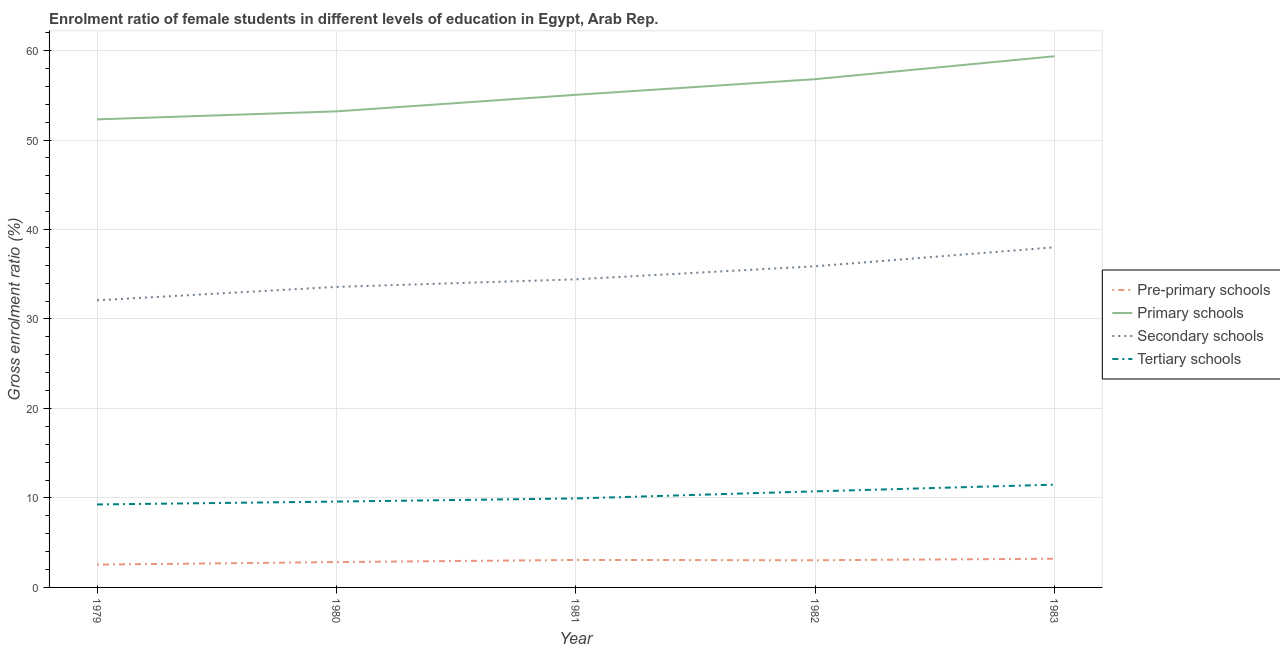How many different coloured lines are there?
Offer a terse response. 4. Does the line corresponding to gross enrolment ratio(male) in primary schools intersect with the line corresponding to gross enrolment ratio(male) in secondary schools?
Your answer should be compact. No. Is the number of lines equal to the number of legend labels?
Give a very brief answer. Yes. What is the gross enrolment ratio(male) in pre-primary schools in 1980?
Keep it short and to the point. 2.83. Across all years, what is the maximum gross enrolment ratio(male) in secondary schools?
Your answer should be compact. 38.01. Across all years, what is the minimum gross enrolment ratio(male) in secondary schools?
Keep it short and to the point. 32.09. In which year was the gross enrolment ratio(male) in pre-primary schools maximum?
Provide a short and direct response. 1983. In which year was the gross enrolment ratio(male) in primary schools minimum?
Your response must be concise. 1979. What is the total gross enrolment ratio(male) in tertiary schools in the graph?
Make the answer very short. 51.03. What is the difference between the gross enrolment ratio(male) in tertiary schools in 1979 and that in 1982?
Offer a terse response. -1.47. What is the difference between the gross enrolment ratio(male) in secondary schools in 1981 and the gross enrolment ratio(male) in primary schools in 1980?
Offer a very short reply. -18.77. What is the average gross enrolment ratio(male) in tertiary schools per year?
Your answer should be very brief. 10.21. In the year 1983, what is the difference between the gross enrolment ratio(male) in tertiary schools and gross enrolment ratio(male) in primary schools?
Provide a succinct answer. -47.88. In how many years, is the gross enrolment ratio(male) in primary schools greater than 20 %?
Offer a terse response. 5. What is the ratio of the gross enrolment ratio(male) in pre-primary schools in 1982 to that in 1983?
Your response must be concise. 0.95. Is the gross enrolment ratio(male) in primary schools in 1979 less than that in 1983?
Offer a terse response. Yes. Is the difference between the gross enrolment ratio(male) in pre-primary schools in 1979 and 1980 greater than the difference between the gross enrolment ratio(male) in primary schools in 1979 and 1980?
Your response must be concise. Yes. What is the difference between the highest and the second highest gross enrolment ratio(male) in tertiary schools?
Your response must be concise. 0.75. What is the difference between the highest and the lowest gross enrolment ratio(male) in secondary schools?
Give a very brief answer. 5.92. Is the sum of the gross enrolment ratio(male) in primary schools in 1980 and 1982 greater than the maximum gross enrolment ratio(male) in secondary schools across all years?
Offer a terse response. Yes. Is it the case that in every year, the sum of the gross enrolment ratio(male) in pre-primary schools and gross enrolment ratio(male) in primary schools is greater than the gross enrolment ratio(male) in secondary schools?
Your response must be concise. Yes. How many lines are there?
Keep it short and to the point. 4. How many legend labels are there?
Offer a terse response. 4. How are the legend labels stacked?
Give a very brief answer. Vertical. What is the title of the graph?
Give a very brief answer. Enrolment ratio of female students in different levels of education in Egypt, Arab Rep. Does "Structural Policies" appear as one of the legend labels in the graph?
Ensure brevity in your answer.  No. What is the label or title of the Y-axis?
Provide a succinct answer. Gross enrolment ratio (%). What is the Gross enrolment ratio (%) of Pre-primary schools in 1979?
Provide a short and direct response. 2.55. What is the Gross enrolment ratio (%) of Primary schools in 1979?
Provide a short and direct response. 52.3. What is the Gross enrolment ratio (%) in Secondary schools in 1979?
Offer a terse response. 32.09. What is the Gross enrolment ratio (%) in Tertiary schools in 1979?
Your answer should be very brief. 9.27. What is the Gross enrolment ratio (%) of Pre-primary schools in 1980?
Provide a short and direct response. 2.83. What is the Gross enrolment ratio (%) of Primary schools in 1980?
Offer a terse response. 53.2. What is the Gross enrolment ratio (%) in Secondary schools in 1980?
Provide a short and direct response. 33.58. What is the Gross enrolment ratio (%) in Tertiary schools in 1980?
Provide a succinct answer. 9.59. What is the Gross enrolment ratio (%) in Pre-primary schools in 1981?
Offer a very short reply. 3.07. What is the Gross enrolment ratio (%) in Primary schools in 1981?
Your answer should be very brief. 55.05. What is the Gross enrolment ratio (%) in Secondary schools in 1981?
Your answer should be compact. 34.43. What is the Gross enrolment ratio (%) of Tertiary schools in 1981?
Give a very brief answer. 9.94. What is the Gross enrolment ratio (%) in Pre-primary schools in 1982?
Your answer should be very brief. 3.04. What is the Gross enrolment ratio (%) in Primary schools in 1982?
Your answer should be very brief. 56.8. What is the Gross enrolment ratio (%) of Secondary schools in 1982?
Offer a terse response. 35.89. What is the Gross enrolment ratio (%) of Tertiary schools in 1982?
Provide a short and direct response. 10.74. What is the Gross enrolment ratio (%) in Pre-primary schools in 1983?
Offer a very short reply. 3.21. What is the Gross enrolment ratio (%) in Primary schools in 1983?
Your response must be concise. 59.36. What is the Gross enrolment ratio (%) in Secondary schools in 1983?
Give a very brief answer. 38.01. What is the Gross enrolment ratio (%) of Tertiary schools in 1983?
Provide a succinct answer. 11.49. Across all years, what is the maximum Gross enrolment ratio (%) of Pre-primary schools?
Give a very brief answer. 3.21. Across all years, what is the maximum Gross enrolment ratio (%) in Primary schools?
Offer a terse response. 59.36. Across all years, what is the maximum Gross enrolment ratio (%) in Secondary schools?
Provide a short and direct response. 38.01. Across all years, what is the maximum Gross enrolment ratio (%) of Tertiary schools?
Keep it short and to the point. 11.49. Across all years, what is the minimum Gross enrolment ratio (%) of Pre-primary schools?
Ensure brevity in your answer.  2.55. Across all years, what is the minimum Gross enrolment ratio (%) of Primary schools?
Keep it short and to the point. 52.3. Across all years, what is the minimum Gross enrolment ratio (%) in Secondary schools?
Provide a short and direct response. 32.09. Across all years, what is the minimum Gross enrolment ratio (%) of Tertiary schools?
Provide a succinct answer. 9.27. What is the total Gross enrolment ratio (%) of Pre-primary schools in the graph?
Provide a short and direct response. 14.7. What is the total Gross enrolment ratio (%) in Primary schools in the graph?
Make the answer very short. 276.71. What is the total Gross enrolment ratio (%) of Secondary schools in the graph?
Provide a short and direct response. 174. What is the total Gross enrolment ratio (%) in Tertiary schools in the graph?
Offer a terse response. 51.03. What is the difference between the Gross enrolment ratio (%) of Pre-primary schools in 1979 and that in 1980?
Make the answer very short. -0.28. What is the difference between the Gross enrolment ratio (%) in Primary schools in 1979 and that in 1980?
Offer a terse response. -0.9. What is the difference between the Gross enrolment ratio (%) in Secondary schools in 1979 and that in 1980?
Give a very brief answer. -1.49. What is the difference between the Gross enrolment ratio (%) in Tertiary schools in 1979 and that in 1980?
Give a very brief answer. -0.32. What is the difference between the Gross enrolment ratio (%) in Pre-primary schools in 1979 and that in 1981?
Ensure brevity in your answer.  -0.52. What is the difference between the Gross enrolment ratio (%) of Primary schools in 1979 and that in 1981?
Keep it short and to the point. -2.75. What is the difference between the Gross enrolment ratio (%) of Secondary schools in 1979 and that in 1981?
Give a very brief answer. -2.34. What is the difference between the Gross enrolment ratio (%) of Tertiary schools in 1979 and that in 1981?
Make the answer very short. -0.67. What is the difference between the Gross enrolment ratio (%) of Pre-primary schools in 1979 and that in 1982?
Keep it short and to the point. -0.49. What is the difference between the Gross enrolment ratio (%) in Primary schools in 1979 and that in 1982?
Keep it short and to the point. -4.49. What is the difference between the Gross enrolment ratio (%) of Secondary schools in 1979 and that in 1982?
Make the answer very short. -3.8. What is the difference between the Gross enrolment ratio (%) in Tertiary schools in 1979 and that in 1982?
Your answer should be compact. -1.47. What is the difference between the Gross enrolment ratio (%) of Pre-primary schools in 1979 and that in 1983?
Keep it short and to the point. -0.66. What is the difference between the Gross enrolment ratio (%) in Primary schools in 1979 and that in 1983?
Ensure brevity in your answer.  -7.06. What is the difference between the Gross enrolment ratio (%) in Secondary schools in 1979 and that in 1983?
Your answer should be compact. -5.92. What is the difference between the Gross enrolment ratio (%) in Tertiary schools in 1979 and that in 1983?
Provide a short and direct response. -2.21. What is the difference between the Gross enrolment ratio (%) in Pre-primary schools in 1980 and that in 1981?
Ensure brevity in your answer.  -0.24. What is the difference between the Gross enrolment ratio (%) in Primary schools in 1980 and that in 1981?
Your answer should be very brief. -1.85. What is the difference between the Gross enrolment ratio (%) of Secondary schools in 1980 and that in 1981?
Give a very brief answer. -0.85. What is the difference between the Gross enrolment ratio (%) in Tertiary schools in 1980 and that in 1981?
Offer a very short reply. -0.35. What is the difference between the Gross enrolment ratio (%) of Pre-primary schools in 1980 and that in 1982?
Offer a very short reply. -0.21. What is the difference between the Gross enrolment ratio (%) of Primary schools in 1980 and that in 1982?
Keep it short and to the point. -3.6. What is the difference between the Gross enrolment ratio (%) of Secondary schools in 1980 and that in 1982?
Offer a terse response. -2.3. What is the difference between the Gross enrolment ratio (%) of Tertiary schools in 1980 and that in 1982?
Make the answer very short. -1.14. What is the difference between the Gross enrolment ratio (%) of Pre-primary schools in 1980 and that in 1983?
Your answer should be compact. -0.37. What is the difference between the Gross enrolment ratio (%) in Primary schools in 1980 and that in 1983?
Offer a very short reply. -6.16. What is the difference between the Gross enrolment ratio (%) in Secondary schools in 1980 and that in 1983?
Offer a terse response. -4.43. What is the difference between the Gross enrolment ratio (%) of Tertiary schools in 1980 and that in 1983?
Give a very brief answer. -1.89. What is the difference between the Gross enrolment ratio (%) in Pre-primary schools in 1981 and that in 1982?
Keep it short and to the point. 0.03. What is the difference between the Gross enrolment ratio (%) in Primary schools in 1981 and that in 1982?
Make the answer very short. -1.75. What is the difference between the Gross enrolment ratio (%) of Secondary schools in 1981 and that in 1982?
Your answer should be very brief. -1.46. What is the difference between the Gross enrolment ratio (%) in Tertiary schools in 1981 and that in 1982?
Your answer should be compact. -0.79. What is the difference between the Gross enrolment ratio (%) in Pre-primary schools in 1981 and that in 1983?
Your response must be concise. -0.13. What is the difference between the Gross enrolment ratio (%) of Primary schools in 1981 and that in 1983?
Ensure brevity in your answer.  -4.31. What is the difference between the Gross enrolment ratio (%) in Secondary schools in 1981 and that in 1983?
Offer a very short reply. -3.58. What is the difference between the Gross enrolment ratio (%) of Tertiary schools in 1981 and that in 1983?
Ensure brevity in your answer.  -1.54. What is the difference between the Gross enrolment ratio (%) of Pre-primary schools in 1982 and that in 1983?
Give a very brief answer. -0.17. What is the difference between the Gross enrolment ratio (%) of Primary schools in 1982 and that in 1983?
Provide a succinct answer. -2.56. What is the difference between the Gross enrolment ratio (%) of Secondary schools in 1982 and that in 1983?
Offer a terse response. -2.13. What is the difference between the Gross enrolment ratio (%) in Tertiary schools in 1982 and that in 1983?
Make the answer very short. -0.75. What is the difference between the Gross enrolment ratio (%) in Pre-primary schools in 1979 and the Gross enrolment ratio (%) in Primary schools in 1980?
Make the answer very short. -50.65. What is the difference between the Gross enrolment ratio (%) in Pre-primary schools in 1979 and the Gross enrolment ratio (%) in Secondary schools in 1980?
Make the answer very short. -31.04. What is the difference between the Gross enrolment ratio (%) of Pre-primary schools in 1979 and the Gross enrolment ratio (%) of Tertiary schools in 1980?
Offer a very short reply. -7.05. What is the difference between the Gross enrolment ratio (%) in Primary schools in 1979 and the Gross enrolment ratio (%) in Secondary schools in 1980?
Your answer should be compact. 18.72. What is the difference between the Gross enrolment ratio (%) in Primary schools in 1979 and the Gross enrolment ratio (%) in Tertiary schools in 1980?
Ensure brevity in your answer.  42.71. What is the difference between the Gross enrolment ratio (%) in Secondary schools in 1979 and the Gross enrolment ratio (%) in Tertiary schools in 1980?
Offer a terse response. 22.49. What is the difference between the Gross enrolment ratio (%) in Pre-primary schools in 1979 and the Gross enrolment ratio (%) in Primary schools in 1981?
Give a very brief answer. -52.5. What is the difference between the Gross enrolment ratio (%) in Pre-primary schools in 1979 and the Gross enrolment ratio (%) in Secondary schools in 1981?
Offer a very short reply. -31.88. What is the difference between the Gross enrolment ratio (%) of Pre-primary schools in 1979 and the Gross enrolment ratio (%) of Tertiary schools in 1981?
Make the answer very short. -7.4. What is the difference between the Gross enrolment ratio (%) in Primary schools in 1979 and the Gross enrolment ratio (%) in Secondary schools in 1981?
Your response must be concise. 17.87. What is the difference between the Gross enrolment ratio (%) of Primary schools in 1979 and the Gross enrolment ratio (%) of Tertiary schools in 1981?
Keep it short and to the point. 42.36. What is the difference between the Gross enrolment ratio (%) in Secondary schools in 1979 and the Gross enrolment ratio (%) in Tertiary schools in 1981?
Keep it short and to the point. 22.15. What is the difference between the Gross enrolment ratio (%) in Pre-primary schools in 1979 and the Gross enrolment ratio (%) in Primary schools in 1982?
Give a very brief answer. -54.25. What is the difference between the Gross enrolment ratio (%) in Pre-primary schools in 1979 and the Gross enrolment ratio (%) in Secondary schools in 1982?
Your answer should be compact. -33.34. What is the difference between the Gross enrolment ratio (%) in Pre-primary schools in 1979 and the Gross enrolment ratio (%) in Tertiary schools in 1982?
Keep it short and to the point. -8.19. What is the difference between the Gross enrolment ratio (%) in Primary schools in 1979 and the Gross enrolment ratio (%) in Secondary schools in 1982?
Keep it short and to the point. 16.42. What is the difference between the Gross enrolment ratio (%) in Primary schools in 1979 and the Gross enrolment ratio (%) in Tertiary schools in 1982?
Make the answer very short. 41.57. What is the difference between the Gross enrolment ratio (%) of Secondary schools in 1979 and the Gross enrolment ratio (%) of Tertiary schools in 1982?
Give a very brief answer. 21.35. What is the difference between the Gross enrolment ratio (%) of Pre-primary schools in 1979 and the Gross enrolment ratio (%) of Primary schools in 1983?
Ensure brevity in your answer.  -56.81. What is the difference between the Gross enrolment ratio (%) in Pre-primary schools in 1979 and the Gross enrolment ratio (%) in Secondary schools in 1983?
Your response must be concise. -35.47. What is the difference between the Gross enrolment ratio (%) of Pre-primary schools in 1979 and the Gross enrolment ratio (%) of Tertiary schools in 1983?
Make the answer very short. -8.94. What is the difference between the Gross enrolment ratio (%) of Primary schools in 1979 and the Gross enrolment ratio (%) of Secondary schools in 1983?
Your answer should be compact. 14.29. What is the difference between the Gross enrolment ratio (%) of Primary schools in 1979 and the Gross enrolment ratio (%) of Tertiary schools in 1983?
Give a very brief answer. 40.82. What is the difference between the Gross enrolment ratio (%) in Secondary schools in 1979 and the Gross enrolment ratio (%) in Tertiary schools in 1983?
Provide a short and direct response. 20.6. What is the difference between the Gross enrolment ratio (%) in Pre-primary schools in 1980 and the Gross enrolment ratio (%) in Primary schools in 1981?
Your response must be concise. -52.22. What is the difference between the Gross enrolment ratio (%) in Pre-primary schools in 1980 and the Gross enrolment ratio (%) in Secondary schools in 1981?
Your answer should be compact. -31.6. What is the difference between the Gross enrolment ratio (%) in Pre-primary schools in 1980 and the Gross enrolment ratio (%) in Tertiary schools in 1981?
Give a very brief answer. -7.11. What is the difference between the Gross enrolment ratio (%) in Primary schools in 1980 and the Gross enrolment ratio (%) in Secondary schools in 1981?
Make the answer very short. 18.77. What is the difference between the Gross enrolment ratio (%) in Primary schools in 1980 and the Gross enrolment ratio (%) in Tertiary schools in 1981?
Ensure brevity in your answer.  43.26. What is the difference between the Gross enrolment ratio (%) in Secondary schools in 1980 and the Gross enrolment ratio (%) in Tertiary schools in 1981?
Keep it short and to the point. 23.64. What is the difference between the Gross enrolment ratio (%) of Pre-primary schools in 1980 and the Gross enrolment ratio (%) of Primary schools in 1982?
Your response must be concise. -53.97. What is the difference between the Gross enrolment ratio (%) in Pre-primary schools in 1980 and the Gross enrolment ratio (%) in Secondary schools in 1982?
Keep it short and to the point. -33.06. What is the difference between the Gross enrolment ratio (%) in Pre-primary schools in 1980 and the Gross enrolment ratio (%) in Tertiary schools in 1982?
Provide a short and direct response. -7.91. What is the difference between the Gross enrolment ratio (%) of Primary schools in 1980 and the Gross enrolment ratio (%) of Secondary schools in 1982?
Make the answer very short. 17.31. What is the difference between the Gross enrolment ratio (%) in Primary schools in 1980 and the Gross enrolment ratio (%) in Tertiary schools in 1982?
Your response must be concise. 42.46. What is the difference between the Gross enrolment ratio (%) of Secondary schools in 1980 and the Gross enrolment ratio (%) of Tertiary schools in 1982?
Your response must be concise. 22.85. What is the difference between the Gross enrolment ratio (%) in Pre-primary schools in 1980 and the Gross enrolment ratio (%) in Primary schools in 1983?
Your answer should be compact. -56.53. What is the difference between the Gross enrolment ratio (%) of Pre-primary schools in 1980 and the Gross enrolment ratio (%) of Secondary schools in 1983?
Make the answer very short. -35.18. What is the difference between the Gross enrolment ratio (%) of Pre-primary schools in 1980 and the Gross enrolment ratio (%) of Tertiary schools in 1983?
Keep it short and to the point. -8.65. What is the difference between the Gross enrolment ratio (%) of Primary schools in 1980 and the Gross enrolment ratio (%) of Secondary schools in 1983?
Offer a terse response. 15.19. What is the difference between the Gross enrolment ratio (%) of Primary schools in 1980 and the Gross enrolment ratio (%) of Tertiary schools in 1983?
Keep it short and to the point. 41.72. What is the difference between the Gross enrolment ratio (%) in Secondary schools in 1980 and the Gross enrolment ratio (%) in Tertiary schools in 1983?
Provide a short and direct response. 22.1. What is the difference between the Gross enrolment ratio (%) of Pre-primary schools in 1981 and the Gross enrolment ratio (%) of Primary schools in 1982?
Your answer should be very brief. -53.73. What is the difference between the Gross enrolment ratio (%) of Pre-primary schools in 1981 and the Gross enrolment ratio (%) of Secondary schools in 1982?
Provide a succinct answer. -32.81. What is the difference between the Gross enrolment ratio (%) in Pre-primary schools in 1981 and the Gross enrolment ratio (%) in Tertiary schools in 1982?
Ensure brevity in your answer.  -7.67. What is the difference between the Gross enrolment ratio (%) in Primary schools in 1981 and the Gross enrolment ratio (%) in Secondary schools in 1982?
Your answer should be compact. 19.17. What is the difference between the Gross enrolment ratio (%) in Primary schools in 1981 and the Gross enrolment ratio (%) in Tertiary schools in 1982?
Your answer should be compact. 44.31. What is the difference between the Gross enrolment ratio (%) of Secondary schools in 1981 and the Gross enrolment ratio (%) of Tertiary schools in 1982?
Provide a short and direct response. 23.69. What is the difference between the Gross enrolment ratio (%) in Pre-primary schools in 1981 and the Gross enrolment ratio (%) in Primary schools in 1983?
Give a very brief answer. -56.29. What is the difference between the Gross enrolment ratio (%) of Pre-primary schools in 1981 and the Gross enrolment ratio (%) of Secondary schools in 1983?
Keep it short and to the point. -34.94. What is the difference between the Gross enrolment ratio (%) of Pre-primary schools in 1981 and the Gross enrolment ratio (%) of Tertiary schools in 1983?
Your response must be concise. -8.41. What is the difference between the Gross enrolment ratio (%) of Primary schools in 1981 and the Gross enrolment ratio (%) of Secondary schools in 1983?
Offer a very short reply. 17.04. What is the difference between the Gross enrolment ratio (%) of Primary schools in 1981 and the Gross enrolment ratio (%) of Tertiary schools in 1983?
Offer a terse response. 43.57. What is the difference between the Gross enrolment ratio (%) in Secondary schools in 1981 and the Gross enrolment ratio (%) in Tertiary schools in 1983?
Offer a terse response. 22.94. What is the difference between the Gross enrolment ratio (%) of Pre-primary schools in 1982 and the Gross enrolment ratio (%) of Primary schools in 1983?
Ensure brevity in your answer.  -56.32. What is the difference between the Gross enrolment ratio (%) in Pre-primary schools in 1982 and the Gross enrolment ratio (%) in Secondary schools in 1983?
Keep it short and to the point. -34.97. What is the difference between the Gross enrolment ratio (%) in Pre-primary schools in 1982 and the Gross enrolment ratio (%) in Tertiary schools in 1983?
Your response must be concise. -8.45. What is the difference between the Gross enrolment ratio (%) of Primary schools in 1982 and the Gross enrolment ratio (%) of Secondary schools in 1983?
Keep it short and to the point. 18.78. What is the difference between the Gross enrolment ratio (%) in Primary schools in 1982 and the Gross enrolment ratio (%) in Tertiary schools in 1983?
Your response must be concise. 45.31. What is the difference between the Gross enrolment ratio (%) of Secondary schools in 1982 and the Gross enrolment ratio (%) of Tertiary schools in 1983?
Keep it short and to the point. 24.4. What is the average Gross enrolment ratio (%) in Pre-primary schools per year?
Keep it short and to the point. 2.94. What is the average Gross enrolment ratio (%) of Primary schools per year?
Your answer should be compact. 55.34. What is the average Gross enrolment ratio (%) of Secondary schools per year?
Provide a succinct answer. 34.8. What is the average Gross enrolment ratio (%) of Tertiary schools per year?
Your response must be concise. 10.21. In the year 1979, what is the difference between the Gross enrolment ratio (%) in Pre-primary schools and Gross enrolment ratio (%) in Primary schools?
Make the answer very short. -49.76. In the year 1979, what is the difference between the Gross enrolment ratio (%) in Pre-primary schools and Gross enrolment ratio (%) in Secondary schools?
Keep it short and to the point. -29.54. In the year 1979, what is the difference between the Gross enrolment ratio (%) in Pre-primary schools and Gross enrolment ratio (%) in Tertiary schools?
Provide a short and direct response. -6.72. In the year 1979, what is the difference between the Gross enrolment ratio (%) of Primary schools and Gross enrolment ratio (%) of Secondary schools?
Your answer should be very brief. 20.21. In the year 1979, what is the difference between the Gross enrolment ratio (%) of Primary schools and Gross enrolment ratio (%) of Tertiary schools?
Keep it short and to the point. 43.03. In the year 1979, what is the difference between the Gross enrolment ratio (%) of Secondary schools and Gross enrolment ratio (%) of Tertiary schools?
Your answer should be very brief. 22.82. In the year 1980, what is the difference between the Gross enrolment ratio (%) of Pre-primary schools and Gross enrolment ratio (%) of Primary schools?
Ensure brevity in your answer.  -50.37. In the year 1980, what is the difference between the Gross enrolment ratio (%) of Pre-primary schools and Gross enrolment ratio (%) of Secondary schools?
Offer a very short reply. -30.75. In the year 1980, what is the difference between the Gross enrolment ratio (%) in Pre-primary schools and Gross enrolment ratio (%) in Tertiary schools?
Offer a terse response. -6.76. In the year 1980, what is the difference between the Gross enrolment ratio (%) of Primary schools and Gross enrolment ratio (%) of Secondary schools?
Provide a short and direct response. 19.62. In the year 1980, what is the difference between the Gross enrolment ratio (%) in Primary schools and Gross enrolment ratio (%) in Tertiary schools?
Your answer should be compact. 43.61. In the year 1980, what is the difference between the Gross enrolment ratio (%) of Secondary schools and Gross enrolment ratio (%) of Tertiary schools?
Offer a terse response. 23.99. In the year 1981, what is the difference between the Gross enrolment ratio (%) of Pre-primary schools and Gross enrolment ratio (%) of Primary schools?
Your response must be concise. -51.98. In the year 1981, what is the difference between the Gross enrolment ratio (%) in Pre-primary schools and Gross enrolment ratio (%) in Secondary schools?
Your response must be concise. -31.36. In the year 1981, what is the difference between the Gross enrolment ratio (%) of Pre-primary schools and Gross enrolment ratio (%) of Tertiary schools?
Make the answer very short. -6.87. In the year 1981, what is the difference between the Gross enrolment ratio (%) in Primary schools and Gross enrolment ratio (%) in Secondary schools?
Keep it short and to the point. 20.62. In the year 1981, what is the difference between the Gross enrolment ratio (%) of Primary schools and Gross enrolment ratio (%) of Tertiary schools?
Ensure brevity in your answer.  45.11. In the year 1981, what is the difference between the Gross enrolment ratio (%) in Secondary schools and Gross enrolment ratio (%) in Tertiary schools?
Offer a very short reply. 24.49. In the year 1982, what is the difference between the Gross enrolment ratio (%) of Pre-primary schools and Gross enrolment ratio (%) of Primary schools?
Provide a succinct answer. -53.76. In the year 1982, what is the difference between the Gross enrolment ratio (%) of Pre-primary schools and Gross enrolment ratio (%) of Secondary schools?
Provide a short and direct response. -32.85. In the year 1982, what is the difference between the Gross enrolment ratio (%) in Pre-primary schools and Gross enrolment ratio (%) in Tertiary schools?
Your answer should be very brief. -7.7. In the year 1982, what is the difference between the Gross enrolment ratio (%) of Primary schools and Gross enrolment ratio (%) of Secondary schools?
Your answer should be compact. 20.91. In the year 1982, what is the difference between the Gross enrolment ratio (%) of Primary schools and Gross enrolment ratio (%) of Tertiary schools?
Offer a very short reply. 46.06. In the year 1982, what is the difference between the Gross enrolment ratio (%) of Secondary schools and Gross enrolment ratio (%) of Tertiary schools?
Your response must be concise. 25.15. In the year 1983, what is the difference between the Gross enrolment ratio (%) in Pre-primary schools and Gross enrolment ratio (%) in Primary schools?
Provide a short and direct response. -56.16. In the year 1983, what is the difference between the Gross enrolment ratio (%) in Pre-primary schools and Gross enrolment ratio (%) in Secondary schools?
Provide a succinct answer. -34.81. In the year 1983, what is the difference between the Gross enrolment ratio (%) in Pre-primary schools and Gross enrolment ratio (%) in Tertiary schools?
Your answer should be very brief. -8.28. In the year 1983, what is the difference between the Gross enrolment ratio (%) of Primary schools and Gross enrolment ratio (%) of Secondary schools?
Offer a terse response. 21.35. In the year 1983, what is the difference between the Gross enrolment ratio (%) in Primary schools and Gross enrolment ratio (%) in Tertiary schools?
Provide a short and direct response. 47.88. In the year 1983, what is the difference between the Gross enrolment ratio (%) of Secondary schools and Gross enrolment ratio (%) of Tertiary schools?
Keep it short and to the point. 26.53. What is the ratio of the Gross enrolment ratio (%) in Pre-primary schools in 1979 to that in 1980?
Your answer should be compact. 0.9. What is the ratio of the Gross enrolment ratio (%) in Primary schools in 1979 to that in 1980?
Provide a short and direct response. 0.98. What is the ratio of the Gross enrolment ratio (%) in Secondary schools in 1979 to that in 1980?
Provide a short and direct response. 0.96. What is the ratio of the Gross enrolment ratio (%) of Tertiary schools in 1979 to that in 1980?
Your response must be concise. 0.97. What is the ratio of the Gross enrolment ratio (%) of Pre-primary schools in 1979 to that in 1981?
Your answer should be compact. 0.83. What is the ratio of the Gross enrolment ratio (%) of Primary schools in 1979 to that in 1981?
Ensure brevity in your answer.  0.95. What is the ratio of the Gross enrolment ratio (%) of Secondary schools in 1979 to that in 1981?
Keep it short and to the point. 0.93. What is the ratio of the Gross enrolment ratio (%) of Tertiary schools in 1979 to that in 1981?
Keep it short and to the point. 0.93. What is the ratio of the Gross enrolment ratio (%) in Pre-primary schools in 1979 to that in 1982?
Keep it short and to the point. 0.84. What is the ratio of the Gross enrolment ratio (%) of Primary schools in 1979 to that in 1982?
Ensure brevity in your answer.  0.92. What is the ratio of the Gross enrolment ratio (%) in Secondary schools in 1979 to that in 1982?
Ensure brevity in your answer.  0.89. What is the ratio of the Gross enrolment ratio (%) of Tertiary schools in 1979 to that in 1982?
Ensure brevity in your answer.  0.86. What is the ratio of the Gross enrolment ratio (%) of Pre-primary schools in 1979 to that in 1983?
Provide a short and direct response. 0.8. What is the ratio of the Gross enrolment ratio (%) of Primary schools in 1979 to that in 1983?
Give a very brief answer. 0.88. What is the ratio of the Gross enrolment ratio (%) in Secondary schools in 1979 to that in 1983?
Offer a terse response. 0.84. What is the ratio of the Gross enrolment ratio (%) in Tertiary schools in 1979 to that in 1983?
Give a very brief answer. 0.81. What is the ratio of the Gross enrolment ratio (%) in Pre-primary schools in 1980 to that in 1981?
Ensure brevity in your answer.  0.92. What is the ratio of the Gross enrolment ratio (%) in Primary schools in 1980 to that in 1981?
Provide a short and direct response. 0.97. What is the ratio of the Gross enrolment ratio (%) in Secondary schools in 1980 to that in 1981?
Offer a terse response. 0.98. What is the ratio of the Gross enrolment ratio (%) in Tertiary schools in 1980 to that in 1981?
Ensure brevity in your answer.  0.96. What is the ratio of the Gross enrolment ratio (%) of Pre-primary schools in 1980 to that in 1982?
Provide a succinct answer. 0.93. What is the ratio of the Gross enrolment ratio (%) in Primary schools in 1980 to that in 1982?
Ensure brevity in your answer.  0.94. What is the ratio of the Gross enrolment ratio (%) of Secondary schools in 1980 to that in 1982?
Your answer should be very brief. 0.94. What is the ratio of the Gross enrolment ratio (%) in Tertiary schools in 1980 to that in 1982?
Ensure brevity in your answer.  0.89. What is the ratio of the Gross enrolment ratio (%) of Pre-primary schools in 1980 to that in 1983?
Your response must be concise. 0.88. What is the ratio of the Gross enrolment ratio (%) of Primary schools in 1980 to that in 1983?
Your answer should be very brief. 0.9. What is the ratio of the Gross enrolment ratio (%) in Secondary schools in 1980 to that in 1983?
Offer a very short reply. 0.88. What is the ratio of the Gross enrolment ratio (%) of Tertiary schools in 1980 to that in 1983?
Offer a very short reply. 0.84. What is the ratio of the Gross enrolment ratio (%) of Pre-primary schools in 1981 to that in 1982?
Offer a very short reply. 1.01. What is the ratio of the Gross enrolment ratio (%) of Primary schools in 1981 to that in 1982?
Offer a terse response. 0.97. What is the ratio of the Gross enrolment ratio (%) of Secondary schools in 1981 to that in 1982?
Offer a very short reply. 0.96. What is the ratio of the Gross enrolment ratio (%) in Tertiary schools in 1981 to that in 1982?
Your answer should be compact. 0.93. What is the ratio of the Gross enrolment ratio (%) of Pre-primary schools in 1981 to that in 1983?
Your answer should be very brief. 0.96. What is the ratio of the Gross enrolment ratio (%) of Primary schools in 1981 to that in 1983?
Your answer should be very brief. 0.93. What is the ratio of the Gross enrolment ratio (%) of Secondary schools in 1981 to that in 1983?
Keep it short and to the point. 0.91. What is the ratio of the Gross enrolment ratio (%) of Tertiary schools in 1981 to that in 1983?
Offer a terse response. 0.87. What is the ratio of the Gross enrolment ratio (%) of Pre-primary schools in 1982 to that in 1983?
Your answer should be compact. 0.95. What is the ratio of the Gross enrolment ratio (%) in Primary schools in 1982 to that in 1983?
Give a very brief answer. 0.96. What is the ratio of the Gross enrolment ratio (%) in Secondary schools in 1982 to that in 1983?
Provide a succinct answer. 0.94. What is the ratio of the Gross enrolment ratio (%) in Tertiary schools in 1982 to that in 1983?
Provide a succinct answer. 0.93. What is the difference between the highest and the second highest Gross enrolment ratio (%) of Pre-primary schools?
Offer a terse response. 0.13. What is the difference between the highest and the second highest Gross enrolment ratio (%) of Primary schools?
Keep it short and to the point. 2.56. What is the difference between the highest and the second highest Gross enrolment ratio (%) of Secondary schools?
Your response must be concise. 2.13. What is the difference between the highest and the second highest Gross enrolment ratio (%) of Tertiary schools?
Keep it short and to the point. 0.75. What is the difference between the highest and the lowest Gross enrolment ratio (%) in Pre-primary schools?
Ensure brevity in your answer.  0.66. What is the difference between the highest and the lowest Gross enrolment ratio (%) in Primary schools?
Offer a terse response. 7.06. What is the difference between the highest and the lowest Gross enrolment ratio (%) in Secondary schools?
Give a very brief answer. 5.92. What is the difference between the highest and the lowest Gross enrolment ratio (%) of Tertiary schools?
Your answer should be very brief. 2.21. 